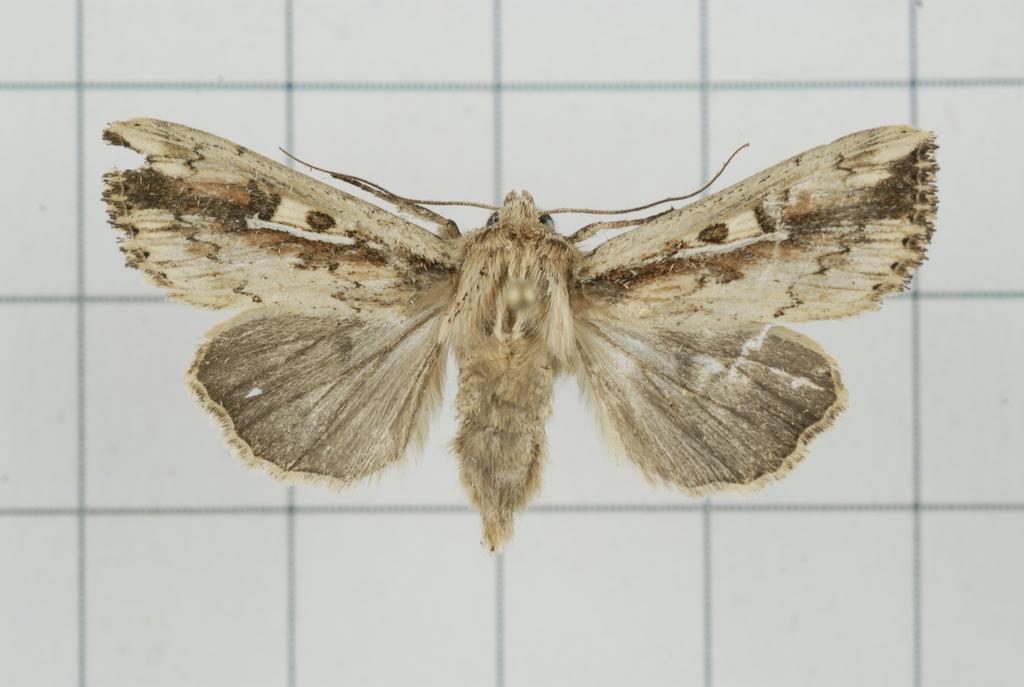In one or two sentences, can you explain what this image depicts? this is the bombycidae in the picture 